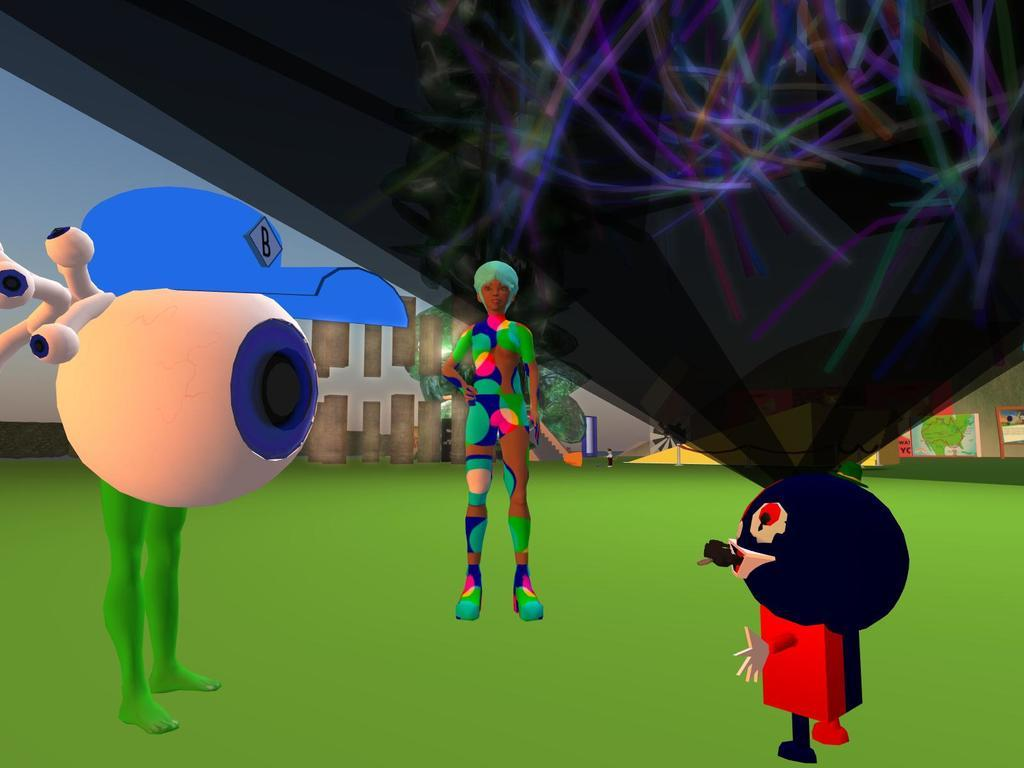What type of image is being described? The image is animated. What can be seen in the middle of the animated image? There are three toys in the middle of the image. What is the surface on which the toys are placed? There is a floor at the bottom of the image. What is visible in the background of the image? There is a wall in the background of the image. Can you tell me how many strangers are interacting with the toys in the image? There are no strangers present in the image; it only features three toys. What type of rock is visible in the image? There is no rock present in the image. 